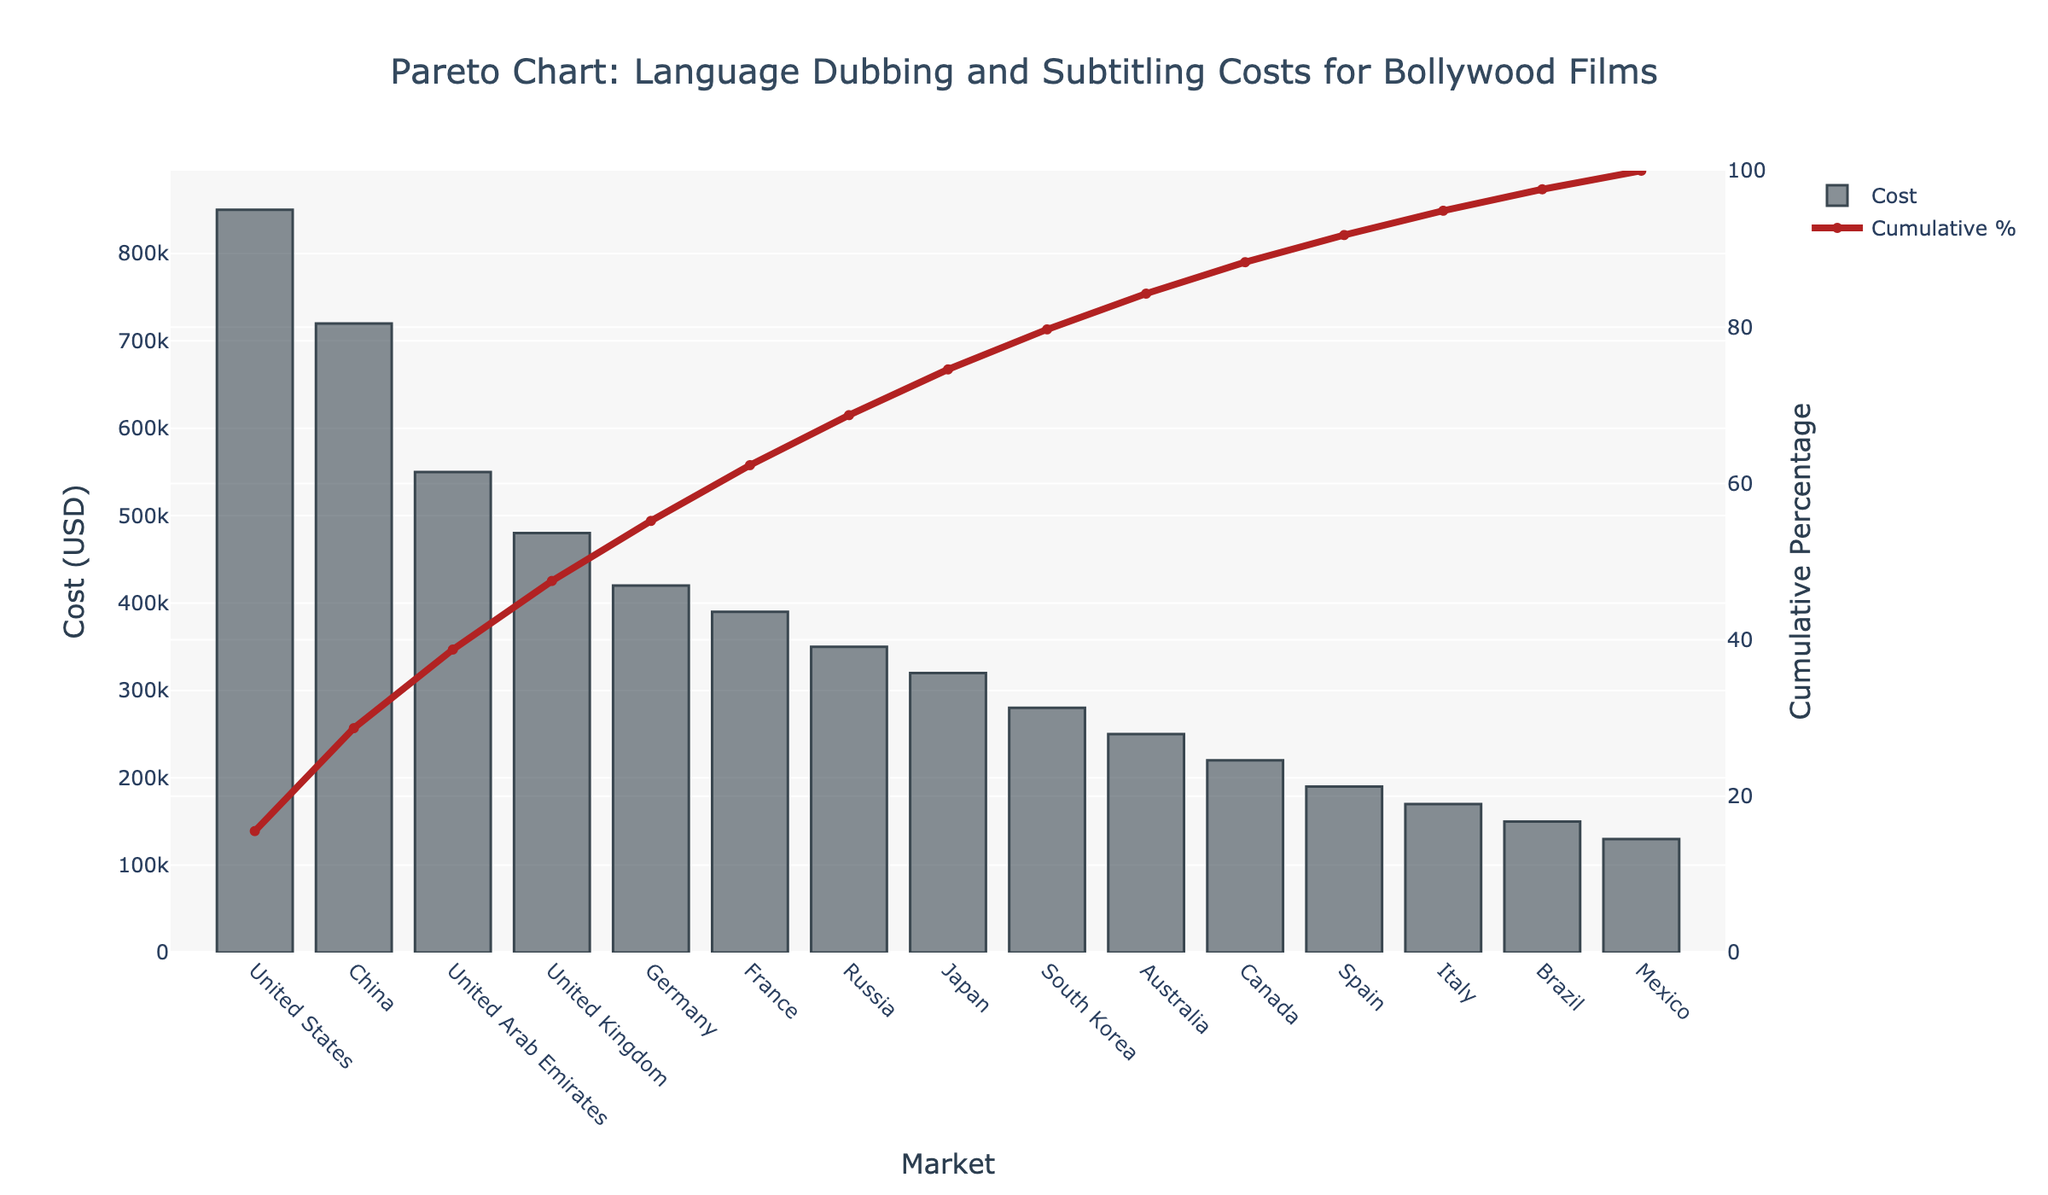What is the total cost for dubbing and subtitling for the United States? The cost for the United States is directly shown as 850,000 USD.
Answer: 850,000 USD Which market has the highest cost for language dubbing and subtitling? The bar for the United States is the highest on the Pareto chart, indicating it has the highest cost.
Answer: United States What percentage of the total cost do the United States and China together represent? The United States has a cost of 850,000 USD and China has 720,000 USD. Their cumulative cost is 1,570,000 USD. The total cost for all markets sums to 5,950,000 USD. Therefore, (1,570,000 / 5,950,000) * 100 equals approximately 26.38%.
Answer: 26.38% How does the cost for the United Arab Emirates compare to that of the United Kingdom? The UAE has a dubbing and subtitling cost of 550,000 USD, whereas the UK has a cost of 480,000 USD, making the UAE higher by 70,000 USD.
Answer: UAE is higher by 70,000 USD What is the cumulative percentage for Germany and France combined? Germany and France have costs of 420,000 USD and 390,000 USD, respectively, giving a cumulative cost of 810,000 USD. The cumulative percentage can be calculated by (810,000 / 5,950,000) * 100, which is approximately 13.61%.
Answer: 13.61% Which market's cost pushes the cumulative percentage over the 50% mark? The cumulative percentage crosses 50% between the costs for China and UAE. Therefore, the UAE market pushes it over 50%.
Answer: UAE What is the cost difference between the markets with the highest and lowest dubbing and subtitling costs? The highest cost is for the United States at 850,000 USD, and the lowest cost is for Mexico at 130,000 USD. The difference is 850,000 - 130,000 = 720,000 USD.
Answer: 720,000 USD How many markets have costs lower than 300,000 USD? From the chart, South Korea, Australia, Canada, Spain, Italy, Brazil, and Mexico have costs lower than 300,000 USD. This counts to 7 markets.
Answer: 7 markets What is the total cost for dubbing and subtitling for countries with costs below that of Russia? The countries with costs below Russia (350,000 USD) are Japan (320,000 USD), South Korea (280,000 USD), Australia (250,000 USD), Canada (220,000 USD), Spain (190,000 USD), Italy (170,000 USD), Brazil (150,000 USD), and Mexico (130,000 USD). Summing these gives a total cost of 1,710,000 USD.
Answer: 1,710,000 USD What is the cumulative percentage at the point where the cost bars switch from light to dark color? The switch to a lighter color in the plot may indicate reaching the cumulative curve of the initial high-cost markets. This transition happens around the cumulative percentage of 50%, observed after the UAE.
Answer: Around 50% 